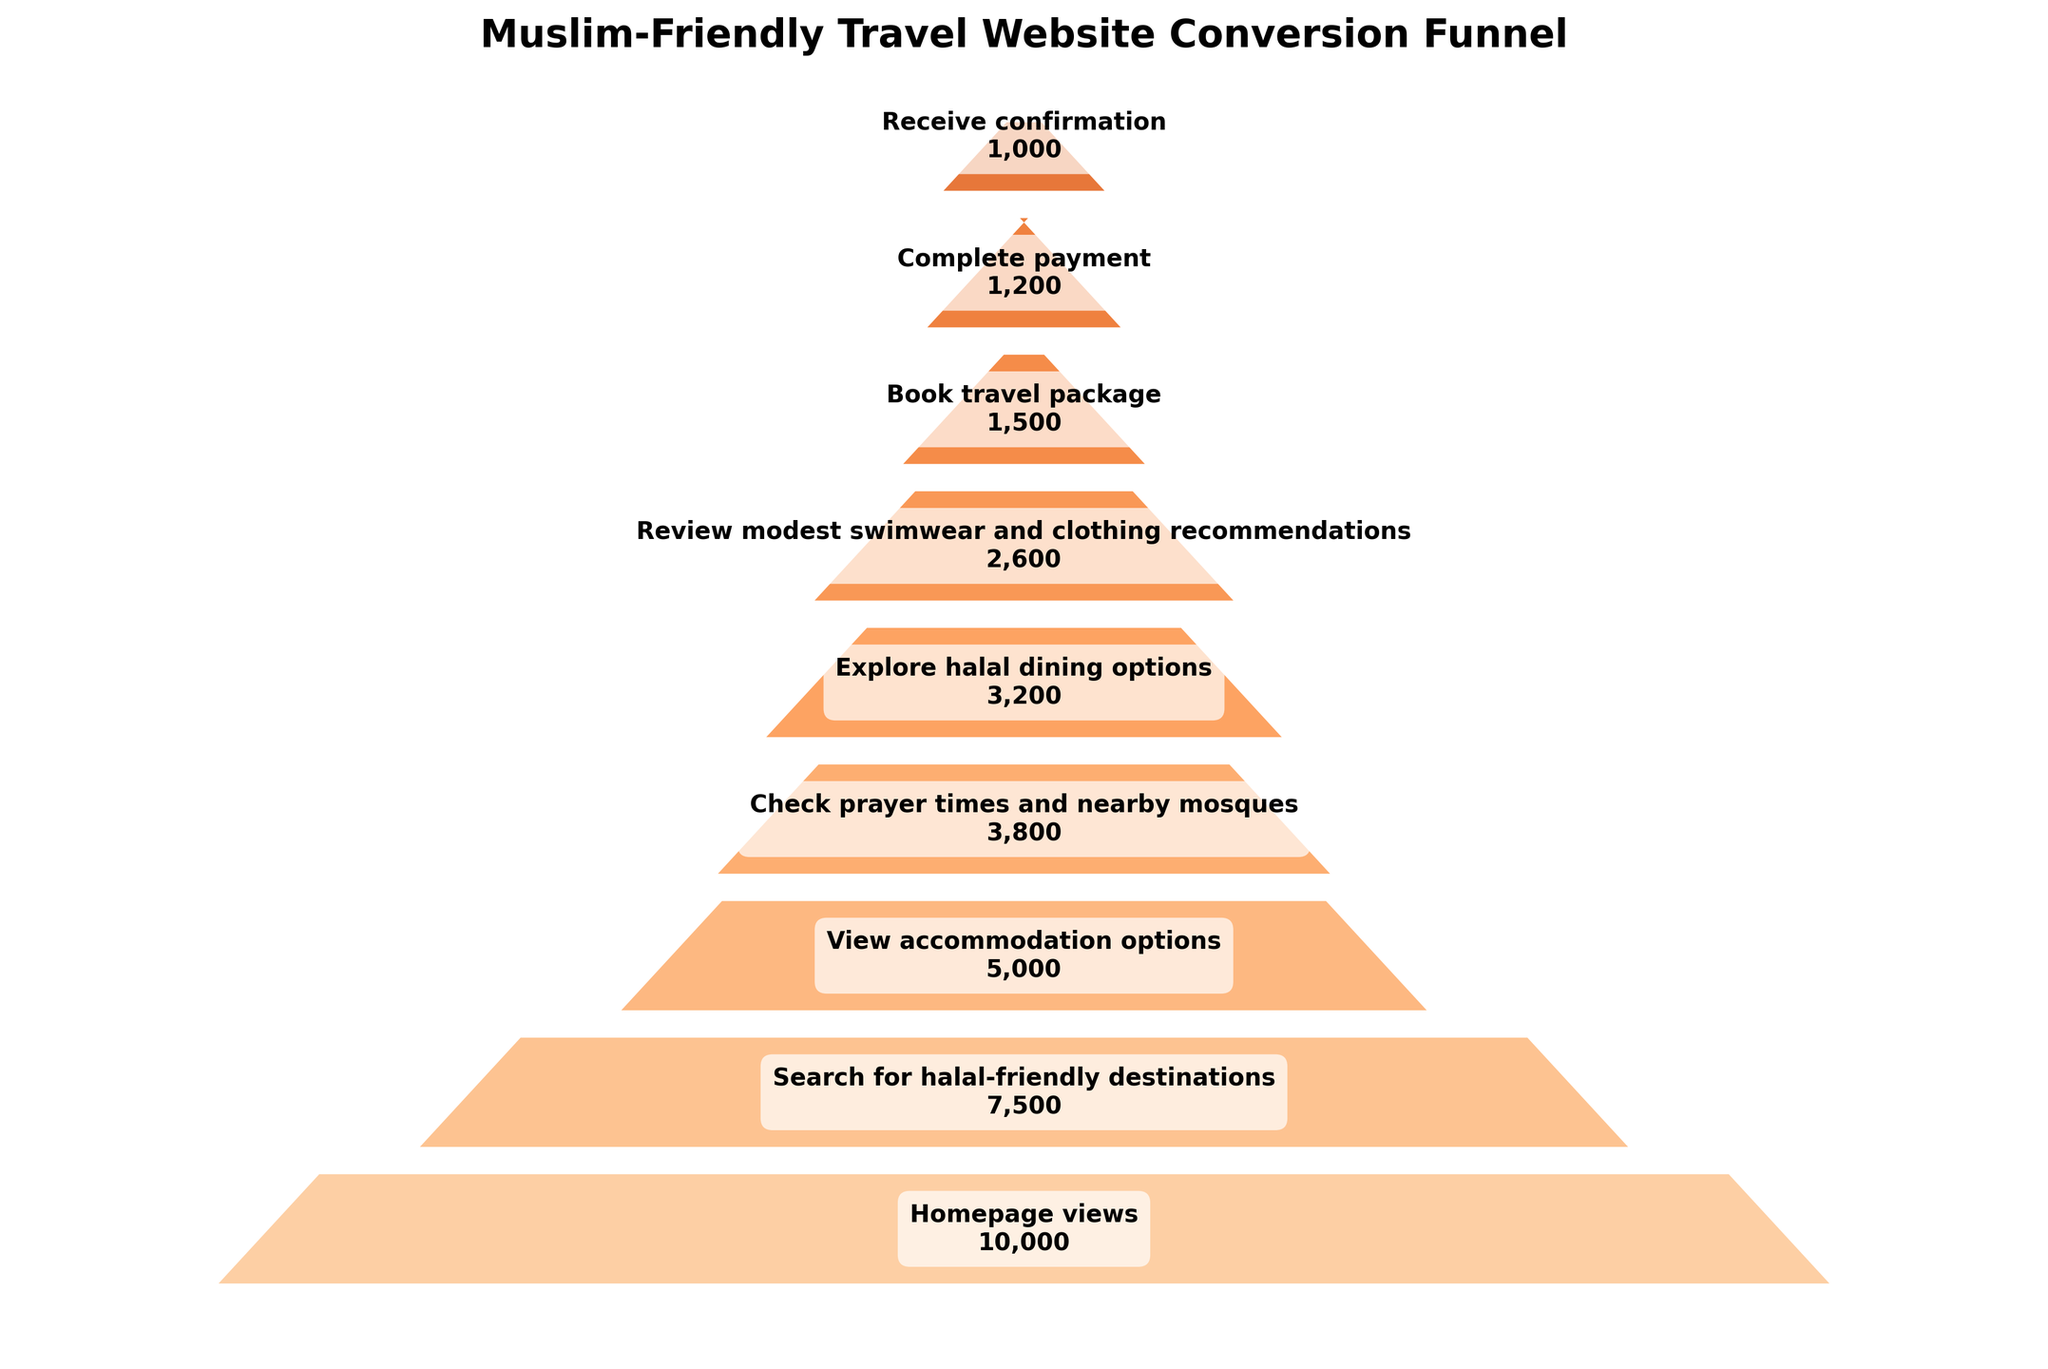How many stages are there in the funnel chart? The funnel chart has 9 unique stages listed from top to bottom, each representing a step in the conversion process.
Answer: 9 Which stage has the highest number of visitors? The stage with the highest number of visitors is at the top of the funnel chart, labeled "Homepage views," with 10,000 visitors.
Answer: Homepage views What is the percentage decrease in visitors from "View accommodation options" to "Check prayer times and nearby mosques"? The number of visitors decreases from 5,000 at "View accommodation options" to 3,800 at "Check prayer times and nearby mosques". The percentage decrease is calculated as ((5000 - 3800) / 5000) * 100 = 24%.
Answer: 24% Compare the number of visitors who searched for halal-friendly destinations to those who completed the payment. Visitors who searched for halal-friendly destinations are 7,500, while those who completed the payment are 1,200. Hence, 7500 is greater than 1200.
Answer: 7500 > 1200 How many visitors are lost between "Book travel package" and "Complete payment"? The number of visitors at "Book travel package" is 1,500, while at "Complete payment," there are 1,200. The decrease in visitors is 1500 - 1200 = 300.
Answer: 300 What's the difference in the number of visitors between "Explore halal dining options" and "Review modest swimwear and clothing recommendations"? "Explore halal dining options" has 3,200 visitors, and "Review modest swimwear and clothing recommendations" has 2,600 visitors. The difference is 3200 - 2600 = 600.
Answer: 600 Which stage has the lowest number of visitors? The stage with the lowest number of visitors is "Receive confirmation," with 1,000 visitors.
Answer: Receive confirmation What is the average number of visitors across all stages? Adding up all visitors: (10000 + 7500 + 5000 + 3800 + 3200 + 2600 + 1500 + 1200 + 1000) = 37900. Dividing by the number of stages (9), the average is 37900 / 9 ≈ 4211.1.
Answer: 4211.1 Identify the stage where the number of visitors first drops below 5,000. The first stage where the number of visitors drops below 5,000 is "Check prayer times and nearby mosques," which has 3,800 visitors.
Answer: Check prayer times and nearby mosques What can be inferred about visitor interest in affiliations to halal-friendly services based on the conversion funnel? From the funnel chart, we observe significant interest initially with 10,000 at the homepage, but there is a notable drop-off at each subsequent stage. This indicates many visitors might not find sufficient appealing options, or are narrowing their decisions as they proceed through the funnel.
Answer: Significant interest initially but considerable drop-off at each subsequent stage 